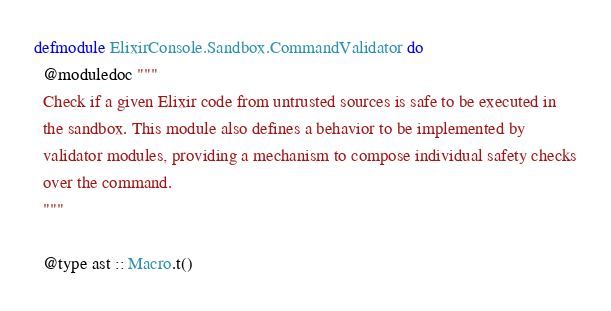<code> <loc_0><loc_0><loc_500><loc_500><_Elixir_>defmodule ElixirConsole.Sandbox.CommandValidator do
  @moduledoc """
  Check if a given Elixir code from untrusted sources is safe to be executed in
  the sandbox. This module also defines a behavior to be implemented by
  validator modules, providing a mechanism to compose individual safety checks
  over the command.
  """

  @type ast :: Macro.t()</code> 